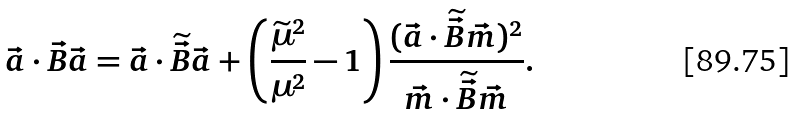<formula> <loc_0><loc_0><loc_500><loc_500>\vec { a } \cdot \vec { B } \vec { a } = \vec { a } \cdot \widetilde { \vec { B } } \vec { a } + \left ( \frac { \widetilde { \mu } ^ { 2 } } { \mu ^ { 2 } } - 1 \right ) \frac { ( \vec { a } \cdot \widetilde { \vec { B } } \vec { m } ) ^ { 2 } } { \vec { m } \cdot \widetilde { \vec { B } } \vec { m } } .</formula> 